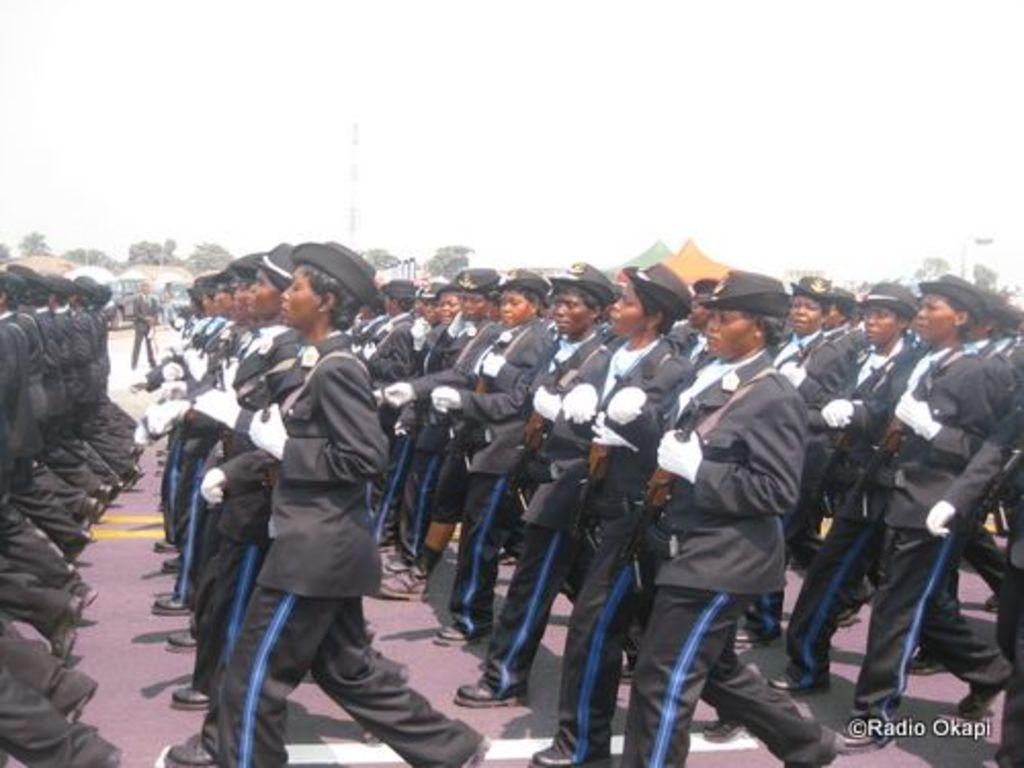Could you give a brief overview of what you see in this image? In the image few people are walking and holding some weapons. Beside them there are some tents and trees. At the top of the image there is sky. 